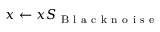Convert formula to latex. <formula><loc_0><loc_0><loc_500><loc_500>x \leftarrow x S _ { B l a c k n o i s e }</formula> 